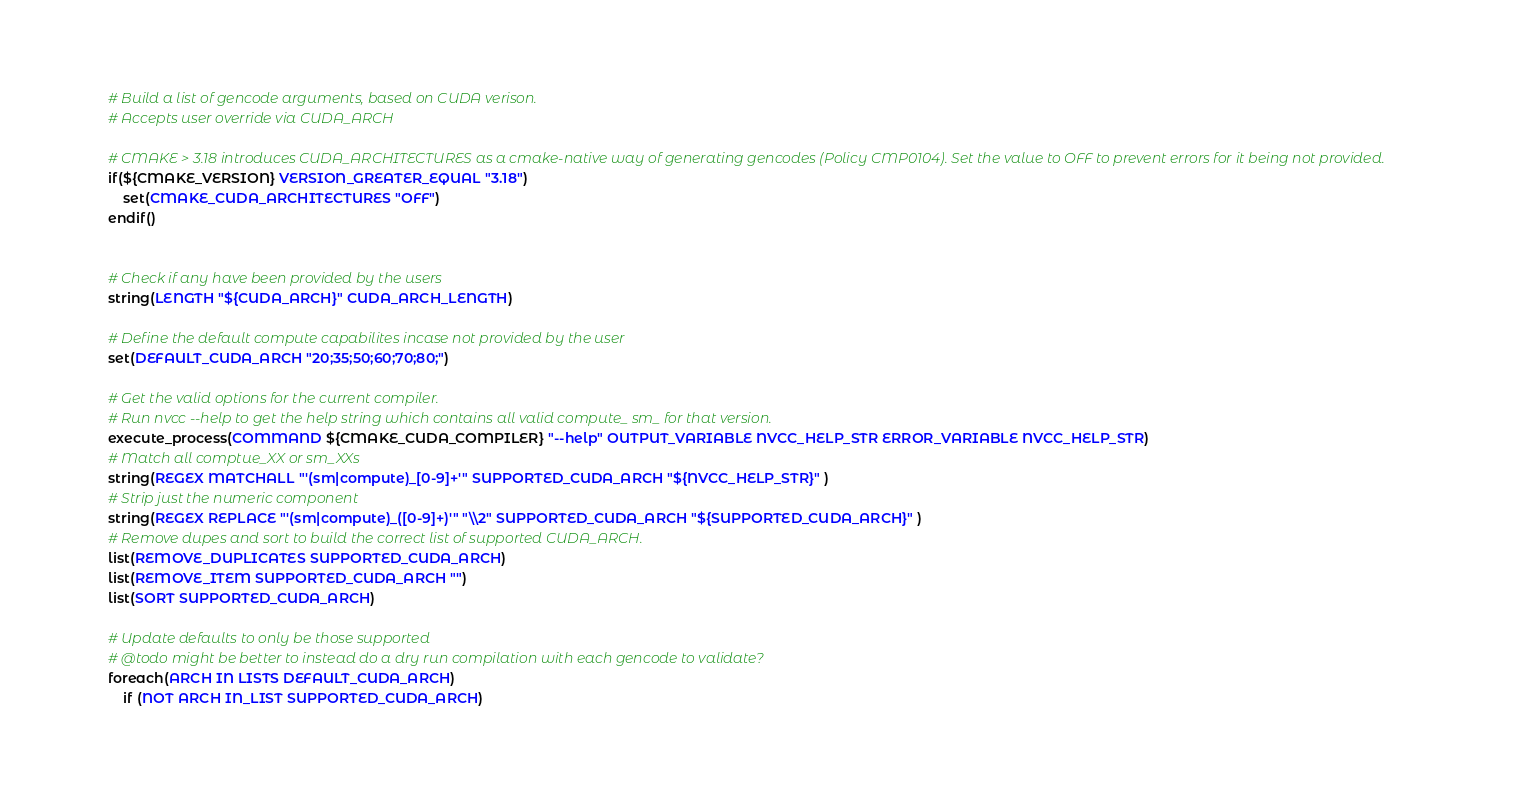Convert code to text. <code><loc_0><loc_0><loc_500><loc_500><_CMake_># Build a list of gencode arguments, based on CUDA verison.
# Accepts user override via CUDA_ARCH

# CMAKE > 3.18 introduces CUDA_ARCHITECTURES as a cmake-native way of generating gencodes (Policy CMP0104). Set the value to OFF to prevent errors for it being not provided.
if(${CMAKE_VERSION} VERSION_GREATER_EQUAL "3.18")
    set(CMAKE_CUDA_ARCHITECTURES "OFF")
endif()


# Check if any have been provided by the users
string(LENGTH "${CUDA_ARCH}" CUDA_ARCH_LENGTH)

# Define the default compute capabilites incase not provided by the user
set(DEFAULT_CUDA_ARCH "20;35;50;60;70;80;")

# Get the valid options for the current compiler.
# Run nvcc --help to get the help string which contains all valid compute_ sm_ for that version.
execute_process(COMMAND ${CMAKE_CUDA_COMPILER} "--help" OUTPUT_VARIABLE NVCC_HELP_STR ERROR_VARIABLE NVCC_HELP_STR)
# Match all comptue_XX or sm_XXs
string(REGEX MATCHALL "'(sm|compute)_[0-9]+'" SUPPORTED_CUDA_ARCH "${NVCC_HELP_STR}" )
# Strip just the numeric component
string(REGEX REPLACE "'(sm|compute)_([0-9]+)'" "\\2" SUPPORTED_CUDA_ARCH "${SUPPORTED_CUDA_ARCH}" )
# Remove dupes and sort to build the correct list of supported CUDA_ARCH.
list(REMOVE_DUPLICATES SUPPORTED_CUDA_ARCH)
list(REMOVE_ITEM SUPPORTED_CUDA_ARCH "")
list(SORT SUPPORTED_CUDA_ARCH)

# Update defaults to only be those supported
# @todo might be better to instead do a dry run compilation with each gencode to validate?
foreach(ARCH IN LISTS DEFAULT_CUDA_ARCH)
    if (NOT ARCH IN_LIST SUPPORTED_CUDA_ARCH)</code> 